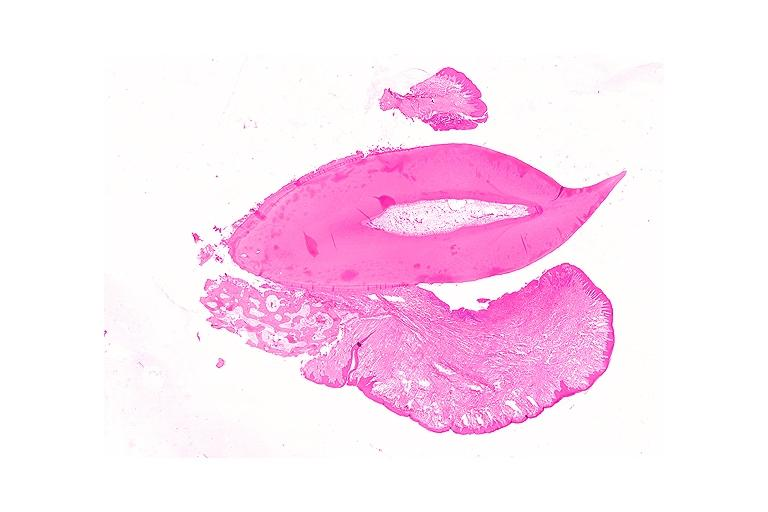does this image show periodontal fibroma?
Answer the question using a single word or phrase. Yes 